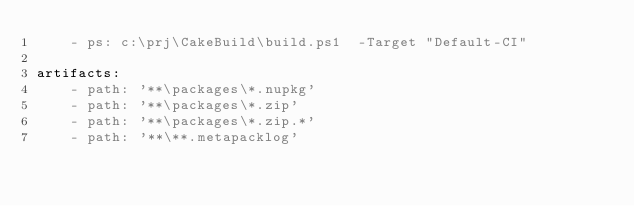Convert code to text. <code><loc_0><loc_0><loc_500><loc_500><_YAML_>    - ps: c:\prj\CakeBuild\build.ps1  -Target "Default-CI" 

artifacts:
    - path: '**\packages\*.nupkg'
    - path: '**\packages\*.zip'
    - path: '**\packages\*.zip.*'
    - path: '**\**.metapacklog'</code> 